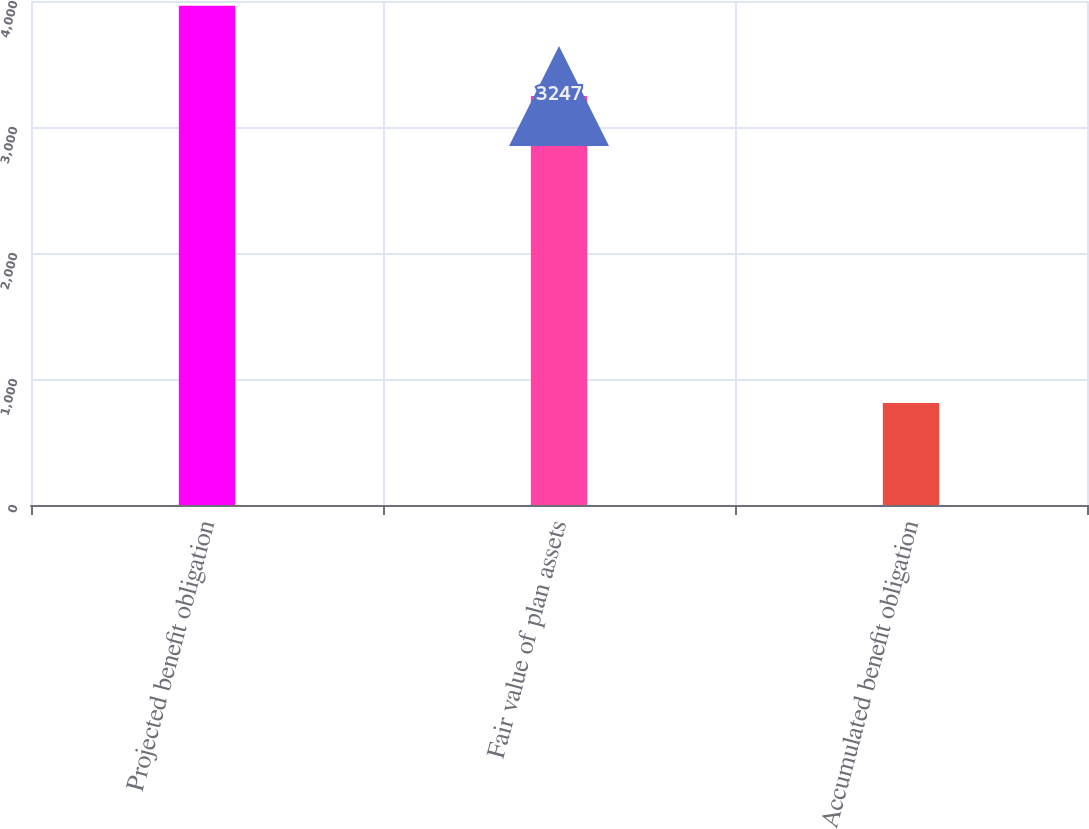Convert chart to OTSL. <chart><loc_0><loc_0><loc_500><loc_500><bar_chart><fcel>Projected benefit obligation<fcel>Fair value of plan assets<fcel>Accumulated benefit obligation<nl><fcel>3963<fcel>3247<fcel>810<nl></chart> 